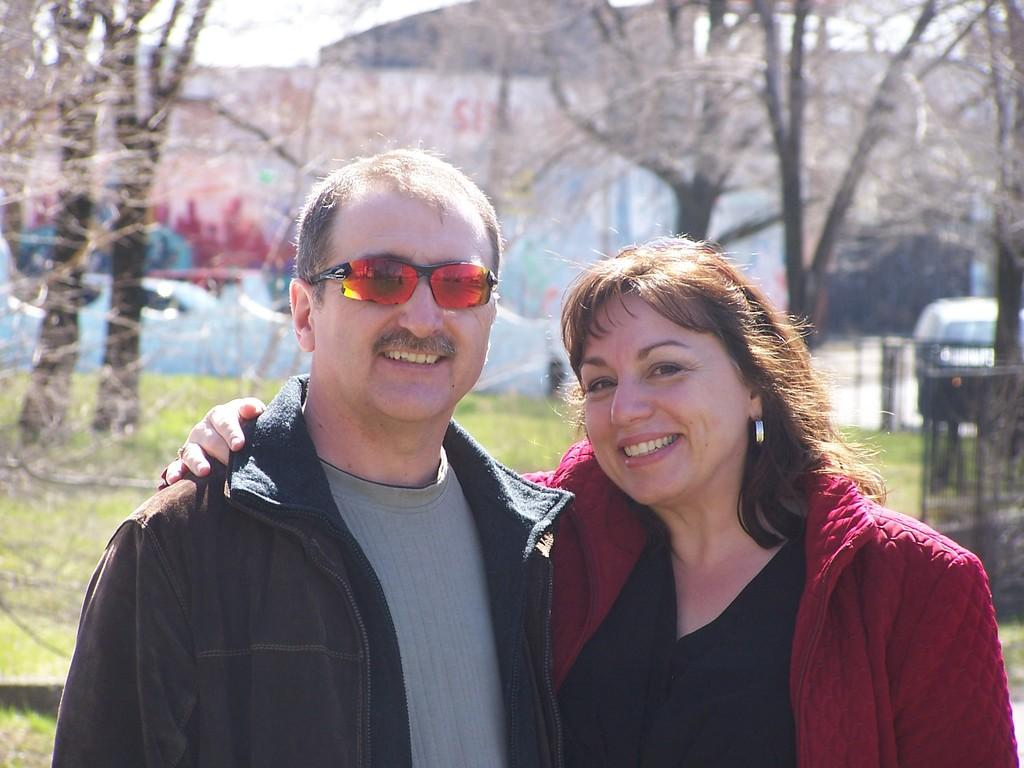How many people are in the image? There are two people in the image, a man and a woman. What is the man wearing in the image? The man is wearing sunglasses in the image. What type of vegetation can be seen in the image? There are trees and grass visible in the image. What is on the wall in the image? There is a painting on a wall in the image. What type of steel is used in the frame of the painting in the image? There is no information about the frame of the painting or the use of steel in the image. 